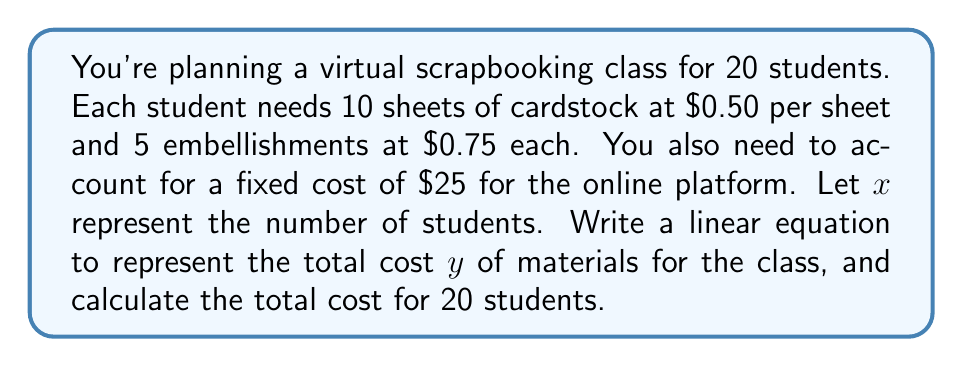What is the answer to this math problem? Let's break this down step-by-step:

1) First, let's identify the components of our linear equation:
   - Fixed cost: $25 for the online platform
   - Variable costs per student:
     * 10 sheets of cardstock at $0.50 each: $10 × $0.50 = $5
     * 5 embellishments at $0.75 each: $5 × $0.75 = $3.75
   - Total variable cost per student: $5 + $3.75 = $8.75

2) Now, we can write our linear equation:
   $y = 25 + 8.75x$
   Where $y$ is the total cost and $x$ is the number of students.

3) To calculate the total cost for 20 students, we substitute $x = 20$ into our equation:

   $y = 25 + 8.75(20)$
   $y = 25 + 175$
   $y = 200$

Therefore, the total cost for a class of 20 students is $200.
Answer: $y = 25 + 8.75x$; $200 